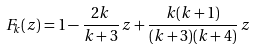<formula> <loc_0><loc_0><loc_500><loc_500>F _ { k } ( z ) = 1 - \frac { 2 k } { k + 3 } \, z + \frac { k ( k + 1 ) } { ( k + 3 ) ( k + 4 ) } \, z</formula> 